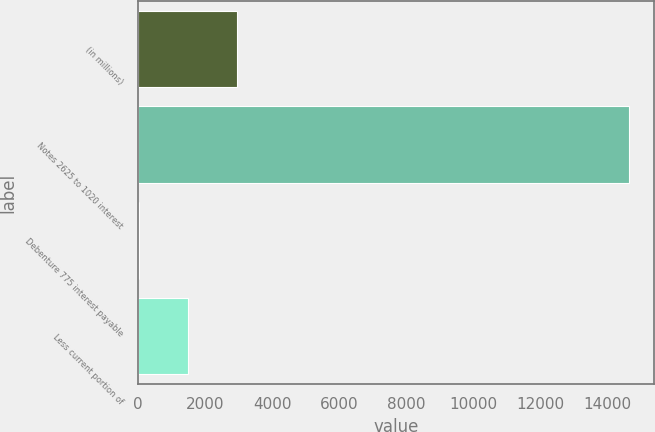Convert chart. <chart><loc_0><loc_0><loc_500><loc_500><bar_chart><fcel>(in millions)<fcel>Notes 2625 to 1020 interest<fcel>Debenture 775 interest payable<fcel>Less current portion of<nl><fcel>2963.8<fcel>14651<fcel>42<fcel>1502.9<nl></chart> 